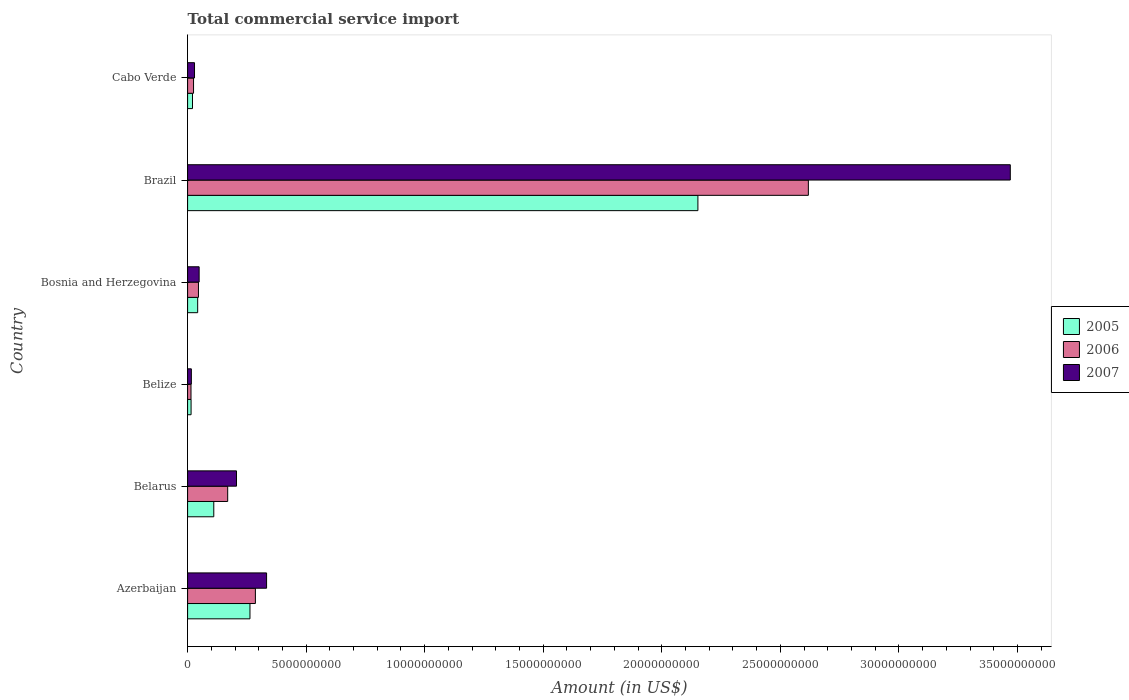How many different coloured bars are there?
Provide a short and direct response. 3. Are the number of bars per tick equal to the number of legend labels?
Offer a terse response. Yes. How many bars are there on the 2nd tick from the top?
Your answer should be compact. 3. What is the label of the 6th group of bars from the top?
Ensure brevity in your answer.  Azerbaijan. What is the total commercial service import in 2007 in Brazil?
Your answer should be compact. 3.47e+1. Across all countries, what is the maximum total commercial service import in 2005?
Your answer should be very brief. 2.15e+1. Across all countries, what is the minimum total commercial service import in 2005?
Your response must be concise. 1.47e+08. In which country was the total commercial service import in 2006 minimum?
Your answer should be very brief. Belize. What is the total total commercial service import in 2005 in the graph?
Provide a succinct answer. 2.60e+1. What is the difference between the total commercial service import in 2007 in Brazil and that in Cabo Verde?
Offer a very short reply. 3.44e+1. What is the difference between the total commercial service import in 2006 in Bosnia and Herzegovina and the total commercial service import in 2007 in Cabo Verde?
Make the answer very short. 1.66e+08. What is the average total commercial service import in 2007 per country?
Offer a terse response. 6.84e+09. What is the difference between the total commercial service import in 2007 and total commercial service import in 2006 in Cabo Verde?
Your answer should be very brief. 4.12e+07. What is the ratio of the total commercial service import in 2007 in Belarus to that in Belize?
Your answer should be very brief. 12.97. What is the difference between the highest and the second highest total commercial service import in 2006?
Your answer should be very brief. 2.33e+1. What is the difference between the highest and the lowest total commercial service import in 2007?
Provide a succinct answer. 3.45e+1. What does the 1st bar from the top in Belize represents?
Provide a short and direct response. 2007. Are all the bars in the graph horizontal?
Ensure brevity in your answer.  Yes. How many countries are there in the graph?
Offer a terse response. 6. What is the difference between two consecutive major ticks on the X-axis?
Your answer should be compact. 5.00e+09. Are the values on the major ticks of X-axis written in scientific E-notation?
Offer a terse response. No. Does the graph contain grids?
Offer a very short reply. No. What is the title of the graph?
Give a very brief answer. Total commercial service import. What is the label or title of the X-axis?
Your answer should be compact. Amount (in US$). What is the label or title of the Y-axis?
Offer a very short reply. Country. What is the Amount (in US$) of 2005 in Azerbaijan?
Offer a terse response. 2.63e+09. What is the Amount (in US$) of 2006 in Azerbaijan?
Ensure brevity in your answer.  2.86e+09. What is the Amount (in US$) in 2007 in Azerbaijan?
Provide a succinct answer. 3.33e+09. What is the Amount (in US$) of 2005 in Belarus?
Your answer should be compact. 1.10e+09. What is the Amount (in US$) of 2006 in Belarus?
Give a very brief answer. 1.69e+09. What is the Amount (in US$) in 2007 in Belarus?
Keep it short and to the point. 2.06e+09. What is the Amount (in US$) of 2005 in Belize?
Provide a short and direct response. 1.47e+08. What is the Amount (in US$) of 2006 in Belize?
Your response must be concise. 1.43e+08. What is the Amount (in US$) of 2007 in Belize?
Keep it short and to the point. 1.59e+08. What is the Amount (in US$) in 2005 in Bosnia and Herzegovina?
Provide a succinct answer. 4.25e+08. What is the Amount (in US$) in 2006 in Bosnia and Herzegovina?
Your response must be concise. 4.58e+08. What is the Amount (in US$) in 2007 in Bosnia and Herzegovina?
Offer a terse response. 4.87e+08. What is the Amount (in US$) in 2005 in Brazil?
Ensure brevity in your answer.  2.15e+1. What is the Amount (in US$) of 2006 in Brazil?
Provide a short and direct response. 2.62e+1. What is the Amount (in US$) in 2007 in Brazil?
Offer a very short reply. 3.47e+1. What is the Amount (in US$) of 2005 in Cabo Verde?
Make the answer very short. 2.07e+08. What is the Amount (in US$) in 2006 in Cabo Verde?
Provide a short and direct response. 2.51e+08. What is the Amount (in US$) in 2007 in Cabo Verde?
Offer a very short reply. 2.92e+08. Across all countries, what is the maximum Amount (in US$) in 2005?
Your answer should be compact. 2.15e+1. Across all countries, what is the maximum Amount (in US$) in 2006?
Provide a short and direct response. 2.62e+1. Across all countries, what is the maximum Amount (in US$) in 2007?
Offer a very short reply. 3.47e+1. Across all countries, what is the minimum Amount (in US$) of 2005?
Provide a short and direct response. 1.47e+08. Across all countries, what is the minimum Amount (in US$) in 2006?
Your answer should be very brief. 1.43e+08. Across all countries, what is the minimum Amount (in US$) of 2007?
Provide a succinct answer. 1.59e+08. What is the total Amount (in US$) of 2005 in the graph?
Your answer should be compact. 2.60e+1. What is the total Amount (in US$) of 2006 in the graph?
Offer a terse response. 3.16e+1. What is the total Amount (in US$) of 2007 in the graph?
Offer a very short reply. 4.10e+1. What is the difference between the Amount (in US$) in 2005 in Azerbaijan and that in Belarus?
Provide a succinct answer. 1.53e+09. What is the difference between the Amount (in US$) in 2006 in Azerbaijan and that in Belarus?
Your answer should be very brief. 1.17e+09. What is the difference between the Amount (in US$) in 2007 in Azerbaijan and that in Belarus?
Provide a succinct answer. 1.27e+09. What is the difference between the Amount (in US$) of 2005 in Azerbaijan and that in Belize?
Keep it short and to the point. 2.48e+09. What is the difference between the Amount (in US$) of 2006 in Azerbaijan and that in Belize?
Give a very brief answer. 2.72e+09. What is the difference between the Amount (in US$) in 2007 in Azerbaijan and that in Belize?
Provide a succinct answer. 3.17e+09. What is the difference between the Amount (in US$) in 2005 in Azerbaijan and that in Bosnia and Herzegovina?
Provide a succinct answer. 2.21e+09. What is the difference between the Amount (in US$) in 2006 in Azerbaijan and that in Bosnia and Herzegovina?
Offer a very short reply. 2.40e+09. What is the difference between the Amount (in US$) of 2007 in Azerbaijan and that in Bosnia and Herzegovina?
Provide a succinct answer. 2.84e+09. What is the difference between the Amount (in US$) of 2005 in Azerbaijan and that in Brazil?
Your answer should be compact. -1.89e+1. What is the difference between the Amount (in US$) in 2006 in Azerbaijan and that in Brazil?
Ensure brevity in your answer.  -2.33e+1. What is the difference between the Amount (in US$) in 2007 in Azerbaijan and that in Brazil?
Provide a short and direct response. -3.14e+1. What is the difference between the Amount (in US$) of 2005 in Azerbaijan and that in Cabo Verde?
Make the answer very short. 2.42e+09. What is the difference between the Amount (in US$) of 2006 in Azerbaijan and that in Cabo Verde?
Give a very brief answer. 2.61e+09. What is the difference between the Amount (in US$) in 2007 in Azerbaijan and that in Cabo Verde?
Offer a terse response. 3.04e+09. What is the difference between the Amount (in US$) of 2005 in Belarus and that in Belize?
Keep it short and to the point. 9.57e+08. What is the difference between the Amount (in US$) of 2006 in Belarus and that in Belize?
Ensure brevity in your answer.  1.55e+09. What is the difference between the Amount (in US$) of 2007 in Belarus and that in Belize?
Your response must be concise. 1.90e+09. What is the difference between the Amount (in US$) in 2005 in Belarus and that in Bosnia and Herzegovina?
Keep it short and to the point. 6.79e+08. What is the difference between the Amount (in US$) of 2006 in Belarus and that in Bosnia and Herzegovina?
Provide a succinct answer. 1.23e+09. What is the difference between the Amount (in US$) in 2007 in Belarus and that in Bosnia and Herzegovina?
Provide a succinct answer. 1.58e+09. What is the difference between the Amount (in US$) in 2005 in Belarus and that in Brazil?
Offer a very short reply. -2.04e+1. What is the difference between the Amount (in US$) of 2006 in Belarus and that in Brazil?
Ensure brevity in your answer.  -2.45e+1. What is the difference between the Amount (in US$) in 2007 in Belarus and that in Brazil?
Make the answer very short. -3.26e+1. What is the difference between the Amount (in US$) of 2005 in Belarus and that in Cabo Verde?
Your response must be concise. 8.97e+08. What is the difference between the Amount (in US$) of 2006 in Belarus and that in Cabo Verde?
Your answer should be very brief. 1.44e+09. What is the difference between the Amount (in US$) in 2007 in Belarus and that in Cabo Verde?
Keep it short and to the point. 1.77e+09. What is the difference between the Amount (in US$) in 2005 in Belize and that in Bosnia and Herzegovina?
Provide a short and direct response. -2.78e+08. What is the difference between the Amount (in US$) of 2006 in Belize and that in Bosnia and Herzegovina?
Your answer should be very brief. -3.15e+08. What is the difference between the Amount (in US$) in 2007 in Belize and that in Bosnia and Herzegovina?
Give a very brief answer. -3.28e+08. What is the difference between the Amount (in US$) in 2005 in Belize and that in Brazil?
Offer a terse response. -2.14e+1. What is the difference between the Amount (in US$) of 2006 in Belize and that in Brazil?
Offer a very short reply. -2.60e+1. What is the difference between the Amount (in US$) in 2007 in Belize and that in Brazil?
Offer a very short reply. -3.45e+1. What is the difference between the Amount (in US$) in 2005 in Belize and that in Cabo Verde?
Your response must be concise. -5.98e+07. What is the difference between the Amount (in US$) in 2006 in Belize and that in Cabo Verde?
Your answer should be very brief. -1.08e+08. What is the difference between the Amount (in US$) of 2007 in Belize and that in Cabo Verde?
Make the answer very short. -1.33e+08. What is the difference between the Amount (in US$) in 2005 in Bosnia and Herzegovina and that in Brazil?
Ensure brevity in your answer.  -2.11e+1. What is the difference between the Amount (in US$) of 2006 in Bosnia and Herzegovina and that in Brazil?
Provide a succinct answer. -2.57e+1. What is the difference between the Amount (in US$) of 2007 in Bosnia and Herzegovina and that in Brazil?
Your answer should be very brief. -3.42e+1. What is the difference between the Amount (in US$) of 2005 in Bosnia and Herzegovina and that in Cabo Verde?
Ensure brevity in your answer.  2.18e+08. What is the difference between the Amount (in US$) in 2006 in Bosnia and Herzegovina and that in Cabo Verde?
Offer a terse response. 2.07e+08. What is the difference between the Amount (in US$) in 2007 in Bosnia and Herzegovina and that in Cabo Verde?
Provide a succinct answer. 1.94e+08. What is the difference between the Amount (in US$) in 2005 in Brazil and that in Cabo Verde?
Offer a very short reply. 2.13e+1. What is the difference between the Amount (in US$) in 2006 in Brazil and that in Cabo Verde?
Make the answer very short. 2.59e+1. What is the difference between the Amount (in US$) in 2007 in Brazil and that in Cabo Verde?
Ensure brevity in your answer.  3.44e+1. What is the difference between the Amount (in US$) in 2005 in Azerbaijan and the Amount (in US$) in 2006 in Belarus?
Your response must be concise. 9.40e+08. What is the difference between the Amount (in US$) of 2005 in Azerbaijan and the Amount (in US$) of 2007 in Belarus?
Keep it short and to the point. 5.68e+08. What is the difference between the Amount (in US$) in 2006 in Azerbaijan and the Amount (in US$) in 2007 in Belarus?
Your answer should be compact. 7.97e+08. What is the difference between the Amount (in US$) of 2005 in Azerbaijan and the Amount (in US$) of 2006 in Belize?
Your answer should be very brief. 2.49e+09. What is the difference between the Amount (in US$) of 2005 in Azerbaijan and the Amount (in US$) of 2007 in Belize?
Give a very brief answer. 2.47e+09. What is the difference between the Amount (in US$) in 2006 in Azerbaijan and the Amount (in US$) in 2007 in Belize?
Your answer should be compact. 2.70e+09. What is the difference between the Amount (in US$) of 2005 in Azerbaijan and the Amount (in US$) of 2006 in Bosnia and Herzegovina?
Offer a very short reply. 2.17e+09. What is the difference between the Amount (in US$) in 2005 in Azerbaijan and the Amount (in US$) in 2007 in Bosnia and Herzegovina?
Your answer should be compact. 2.14e+09. What is the difference between the Amount (in US$) of 2006 in Azerbaijan and the Amount (in US$) of 2007 in Bosnia and Herzegovina?
Offer a very short reply. 2.37e+09. What is the difference between the Amount (in US$) of 2005 in Azerbaijan and the Amount (in US$) of 2006 in Brazil?
Make the answer very short. -2.36e+1. What is the difference between the Amount (in US$) of 2005 in Azerbaijan and the Amount (in US$) of 2007 in Brazil?
Provide a succinct answer. -3.21e+1. What is the difference between the Amount (in US$) of 2006 in Azerbaijan and the Amount (in US$) of 2007 in Brazil?
Ensure brevity in your answer.  -3.18e+1. What is the difference between the Amount (in US$) in 2005 in Azerbaijan and the Amount (in US$) in 2006 in Cabo Verde?
Your answer should be compact. 2.38e+09. What is the difference between the Amount (in US$) of 2005 in Azerbaijan and the Amount (in US$) of 2007 in Cabo Verde?
Provide a short and direct response. 2.34e+09. What is the difference between the Amount (in US$) in 2006 in Azerbaijan and the Amount (in US$) in 2007 in Cabo Verde?
Give a very brief answer. 2.57e+09. What is the difference between the Amount (in US$) of 2005 in Belarus and the Amount (in US$) of 2006 in Belize?
Give a very brief answer. 9.61e+08. What is the difference between the Amount (in US$) of 2005 in Belarus and the Amount (in US$) of 2007 in Belize?
Your response must be concise. 9.45e+08. What is the difference between the Amount (in US$) in 2006 in Belarus and the Amount (in US$) in 2007 in Belize?
Offer a terse response. 1.53e+09. What is the difference between the Amount (in US$) in 2005 in Belarus and the Amount (in US$) in 2006 in Bosnia and Herzegovina?
Your answer should be compact. 6.46e+08. What is the difference between the Amount (in US$) in 2005 in Belarus and the Amount (in US$) in 2007 in Bosnia and Herzegovina?
Your answer should be compact. 6.18e+08. What is the difference between the Amount (in US$) of 2006 in Belarus and the Amount (in US$) of 2007 in Bosnia and Herzegovina?
Provide a short and direct response. 1.20e+09. What is the difference between the Amount (in US$) in 2005 in Belarus and the Amount (in US$) in 2006 in Brazil?
Keep it short and to the point. -2.51e+1. What is the difference between the Amount (in US$) in 2005 in Belarus and the Amount (in US$) in 2007 in Brazil?
Give a very brief answer. -3.36e+1. What is the difference between the Amount (in US$) in 2006 in Belarus and the Amount (in US$) in 2007 in Brazil?
Offer a terse response. -3.30e+1. What is the difference between the Amount (in US$) of 2005 in Belarus and the Amount (in US$) of 2006 in Cabo Verde?
Ensure brevity in your answer.  8.53e+08. What is the difference between the Amount (in US$) of 2005 in Belarus and the Amount (in US$) of 2007 in Cabo Verde?
Give a very brief answer. 8.12e+08. What is the difference between the Amount (in US$) in 2006 in Belarus and the Amount (in US$) in 2007 in Cabo Verde?
Make the answer very short. 1.40e+09. What is the difference between the Amount (in US$) of 2005 in Belize and the Amount (in US$) of 2006 in Bosnia and Herzegovina?
Offer a very short reply. -3.11e+08. What is the difference between the Amount (in US$) in 2005 in Belize and the Amount (in US$) in 2007 in Bosnia and Herzegovina?
Your response must be concise. -3.39e+08. What is the difference between the Amount (in US$) of 2006 in Belize and the Amount (in US$) of 2007 in Bosnia and Herzegovina?
Offer a terse response. -3.43e+08. What is the difference between the Amount (in US$) of 2005 in Belize and the Amount (in US$) of 2006 in Brazil?
Keep it short and to the point. -2.60e+1. What is the difference between the Amount (in US$) of 2005 in Belize and the Amount (in US$) of 2007 in Brazil?
Keep it short and to the point. -3.46e+1. What is the difference between the Amount (in US$) in 2006 in Belize and the Amount (in US$) in 2007 in Brazil?
Give a very brief answer. -3.46e+1. What is the difference between the Amount (in US$) in 2005 in Belize and the Amount (in US$) in 2006 in Cabo Verde?
Offer a terse response. -1.04e+08. What is the difference between the Amount (in US$) of 2005 in Belize and the Amount (in US$) of 2007 in Cabo Verde?
Ensure brevity in your answer.  -1.45e+08. What is the difference between the Amount (in US$) in 2006 in Belize and the Amount (in US$) in 2007 in Cabo Verde?
Your response must be concise. -1.49e+08. What is the difference between the Amount (in US$) in 2005 in Bosnia and Herzegovina and the Amount (in US$) in 2006 in Brazil?
Ensure brevity in your answer.  -2.58e+1. What is the difference between the Amount (in US$) of 2005 in Bosnia and Herzegovina and the Amount (in US$) of 2007 in Brazil?
Ensure brevity in your answer.  -3.43e+1. What is the difference between the Amount (in US$) in 2006 in Bosnia and Herzegovina and the Amount (in US$) in 2007 in Brazil?
Make the answer very short. -3.42e+1. What is the difference between the Amount (in US$) in 2005 in Bosnia and Herzegovina and the Amount (in US$) in 2006 in Cabo Verde?
Your answer should be very brief. 1.74e+08. What is the difference between the Amount (in US$) of 2005 in Bosnia and Herzegovina and the Amount (in US$) of 2007 in Cabo Verde?
Provide a short and direct response. 1.33e+08. What is the difference between the Amount (in US$) of 2006 in Bosnia and Herzegovina and the Amount (in US$) of 2007 in Cabo Verde?
Make the answer very short. 1.66e+08. What is the difference between the Amount (in US$) of 2005 in Brazil and the Amount (in US$) of 2006 in Cabo Verde?
Offer a very short reply. 2.13e+1. What is the difference between the Amount (in US$) of 2005 in Brazil and the Amount (in US$) of 2007 in Cabo Verde?
Offer a very short reply. 2.12e+1. What is the difference between the Amount (in US$) of 2006 in Brazil and the Amount (in US$) of 2007 in Cabo Verde?
Offer a very short reply. 2.59e+1. What is the average Amount (in US$) in 2005 per country?
Your response must be concise. 4.34e+09. What is the average Amount (in US$) in 2006 per country?
Make the answer very short. 5.26e+09. What is the average Amount (in US$) of 2007 per country?
Ensure brevity in your answer.  6.84e+09. What is the difference between the Amount (in US$) in 2005 and Amount (in US$) in 2006 in Azerbaijan?
Your response must be concise. -2.28e+08. What is the difference between the Amount (in US$) of 2005 and Amount (in US$) of 2007 in Azerbaijan?
Offer a very short reply. -7.00e+08. What is the difference between the Amount (in US$) in 2006 and Amount (in US$) in 2007 in Azerbaijan?
Your answer should be very brief. -4.72e+08. What is the difference between the Amount (in US$) of 2005 and Amount (in US$) of 2006 in Belarus?
Keep it short and to the point. -5.87e+08. What is the difference between the Amount (in US$) of 2005 and Amount (in US$) of 2007 in Belarus?
Your response must be concise. -9.58e+08. What is the difference between the Amount (in US$) of 2006 and Amount (in US$) of 2007 in Belarus?
Keep it short and to the point. -3.72e+08. What is the difference between the Amount (in US$) in 2005 and Amount (in US$) in 2006 in Belize?
Offer a terse response. 3.89e+06. What is the difference between the Amount (in US$) in 2005 and Amount (in US$) in 2007 in Belize?
Your answer should be very brief. -1.18e+07. What is the difference between the Amount (in US$) in 2006 and Amount (in US$) in 2007 in Belize?
Offer a very short reply. -1.57e+07. What is the difference between the Amount (in US$) of 2005 and Amount (in US$) of 2006 in Bosnia and Herzegovina?
Provide a short and direct response. -3.32e+07. What is the difference between the Amount (in US$) in 2005 and Amount (in US$) in 2007 in Bosnia and Herzegovina?
Make the answer very short. -6.18e+07. What is the difference between the Amount (in US$) of 2006 and Amount (in US$) of 2007 in Bosnia and Herzegovina?
Offer a terse response. -2.86e+07. What is the difference between the Amount (in US$) in 2005 and Amount (in US$) in 2006 in Brazil?
Give a very brief answer. -4.66e+09. What is the difference between the Amount (in US$) of 2005 and Amount (in US$) of 2007 in Brazil?
Provide a short and direct response. -1.32e+1. What is the difference between the Amount (in US$) of 2006 and Amount (in US$) of 2007 in Brazil?
Provide a succinct answer. -8.52e+09. What is the difference between the Amount (in US$) of 2005 and Amount (in US$) of 2006 in Cabo Verde?
Keep it short and to the point. -4.40e+07. What is the difference between the Amount (in US$) in 2005 and Amount (in US$) in 2007 in Cabo Verde?
Ensure brevity in your answer.  -8.51e+07. What is the difference between the Amount (in US$) in 2006 and Amount (in US$) in 2007 in Cabo Verde?
Your response must be concise. -4.12e+07. What is the ratio of the Amount (in US$) of 2005 in Azerbaijan to that in Belarus?
Ensure brevity in your answer.  2.38. What is the ratio of the Amount (in US$) in 2006 in Azerbaijan to that in Belarus?
Give a very brief answer. 1.69. What is the ratio of the Amount (in US$) in 2007 in Azerbaijan to that in Belarus?
Provide a succinct answer. 1.61. What is the ratio of the Amount (in US$) in 2005 in Azerbaijan to that in Belize?
Offer a very short reply. 17.87. What is the ratio of the Amount (in US$) in 2006 in Azerbaijan to that in Belize?
Your answer should be very brief. 19.95. What is the ratio of the Amount (in US$) of 2007 in Azerbaijan to that in Belize?
Ensure brevity in your answer.  20.95. What is the ratio of the Amount (in US$) in 2005 in Azerbaijan to that in Bosnia and Herzegovina?
Offer a terse response. 6.19. What is the ratio of the Amount (in US$) in 2006 in Azerbaijan to that in Bosnia and Herzegovina?
Provide a short and direct response. 6.24. What is the ratio of the Amount (in US$) in 2007 in Azerbaijan to that in Bosnia and Herzegovina?
Your answer should be very brief. 6.85. What is the ratio of the Amount (in US$) in 2005 in Azerbaijan to that in Brazil?
Keep it short and to the point. 0.12. What is the ratio of the Amount (in US$) in 2006 in Azerbaijan to that in Brazil?
Ensure brevity in your answer.  0.11. What is the ratio of the Amount (in US$) in 2007 in Azerbaijan to that in Brazil?
Ensure brevity in your answer.  0.1. What is the ratio of the Amount (in US$) in 2005 in Azerbaijan to that in Cabo Verde?
Provide a succinct answer. 12.71. What is the ratio of the Amount (in US$) of 2006 in Azerbaijan to that in Cabo Verde?
Offer a terse response. 11.39. What is the ratio of the Amount (in US$) of 2007 in Azerbaijan to that in Cabo Verde?
Your answer should be very brief. 11.4. What is the ratio of the Amount (in US$) in 2005 in Belarus to that in Belize?
Provide a short and direct response. 7.5. What is the ratio of the Amount (in US$) of 2006 in Belarus to that in Belize?
Give a very brief answer. 11.8. What is the ratio of the Amount (in US$) of 2007 in Belarus to that in Belize?
Offer a very short reply. 12.97. What is the ratio of the Amount (in US$) in 2005 in Belarus to that in Bosnia and Herzegovina?
Offer a terse response. 2.6. What is the ratio of the Amount (in US$) in 2006 in Belarus to that in Bosnia and Herzegovina?
Provide a short and direct response. 3.69. What is the ratio of the Amount (in US$) in 2007 in Belarus to that in Bosnia and Herzegovina?
Offer a very short reply. 4.24. What is the ratio of the Amount (in US$) in 2005 in Belarus to that in Brazil?
Your answer should be compact. 0.05. What is the ratio of the Amount (in US$) in 2006 in Belarus to that in Brazil?
Provide a succinct answer. 0.06. What is the ratio of the Amount (in US$) of 2007 in Belarus to that in Brazil?
Your response must be concise. 0.06. What is the ratio of the Amount (in US$) in 2005 in Belarus to that in Cabo Verde?
Ensure brevity in your answer.  5.33. What is the ratio of the Amount (in US$) in 2006 in Belarus to that in Cabo Verde?
Make the answer very short. 6.74. What is the ratio of the Amount (in US$) in 2007 in Belarus to that in Cabo Verde?
Give a very brief answer. 7.06. What is the ratio of the Amount (in US$) of 2005 in Belize to that in Bosnia and Herzegovina?
Your answer should be very brief. 0.35. What is the ratio of the Amount (in US$) in 2006 in Belize to that in Bosnia and Herzegovina?
Ensure brevity in your answer.  0.31. What is the ratio of the Amount (in US$) in 2007 in Belize to that in Bosnia and Herzegovina?
Your answer should be very brief. 0.33. What is the ratio of the Amount (in US$) of 2005 in Belize to that in Brazil?
Offer a terse response. 0.01. What is the ratio of the Amount (in US$) in 2006 in Belize to that in Brazil?
Your answer should be compact. 0.01. What is the ratio of the Amount (in US$) in 2007 in Belize to that in Brazil?
Your answer should be very brief. 0. What is the ratio of the Amount (in US$) of 2005 in Belize to that in Cabo Verde?
Your answer should be very brief. 0.71. What is the ratio of the Amount (in US$) in 2006 in Belize to that in Cabo Verde?
Make the answer very short. 0.57. What is the ratio of the Amount (in US$) of 2007 in Belize to that in Cabo Verde?
Your response must be concise. 0.54. What is the ratio of the Amount (in US$) of 2005 in Bosnia and Herzegovina to that in Brazil?
Give a very brief answer. 0.02. What is the ratio of the Amount (in US$) of 2006 in Bosnia and Herzegovina to that in Brazil?
Make the answer very short. 0.02. What is the ratio of the Amount (in US$) in 2007 in Bosnia and Herzegovina to that in Brazil?
Ensure brevity in your answer.  0.01. What is the ratio of the Amount (in US$) in 2005 in Bosnia and Herzegovina to that in Cabo Verde?
Provide a short and direct response. 2.05. What is the ratio of the Amount (in US$) in 2006 in Bosnia and Herzegovina to that in Cabo Verde?
Your answer should be compact. 1.82. What is the ratio of the Amount (in US$) in 2007 in Bosnia and Herzegovina to that in Cabo Verde?
Keep it short and to the point. 1.67. What is the ratio of the Amount (in US$) of 2005 in Brazil to that in Cabo Verde?
Give a very brief answer. 103.97. What is the ratio of the Amount (in US$) in 2006 in Brazil to that in Cabo Verde?
Your response must be concise. 104.32. What is the ratio of the Amount (in US$) of 2007 in Brazil to that in Cabo Verde?
Keep it short and to the point. 118.77. What is the difference between the highest and the second highest Amount (in US$) in 2005?
Your answer should be compact. 1.89e+1. What is the difference between the highest and the second highest Amount (in US$) in 2006?
Ensure brevity in your answer.  2.33e+1. What is the difference between the highest and the second highest Amount (in US$) in 2007?
Offer a terse response. 3.14e+1. What is the difference between the highest and the lowest Amount (in US$) in 2005?
Make the answer very short. 2.14e+1. What is the difference between the highest and the lowest Amount (in US$) in 2006?
Give a very brief answer. 2.60e+1. What is the difference between the highest and the lowest Amount (in US$) of 2007?
Give a very brief answer. 3.45e+1. 